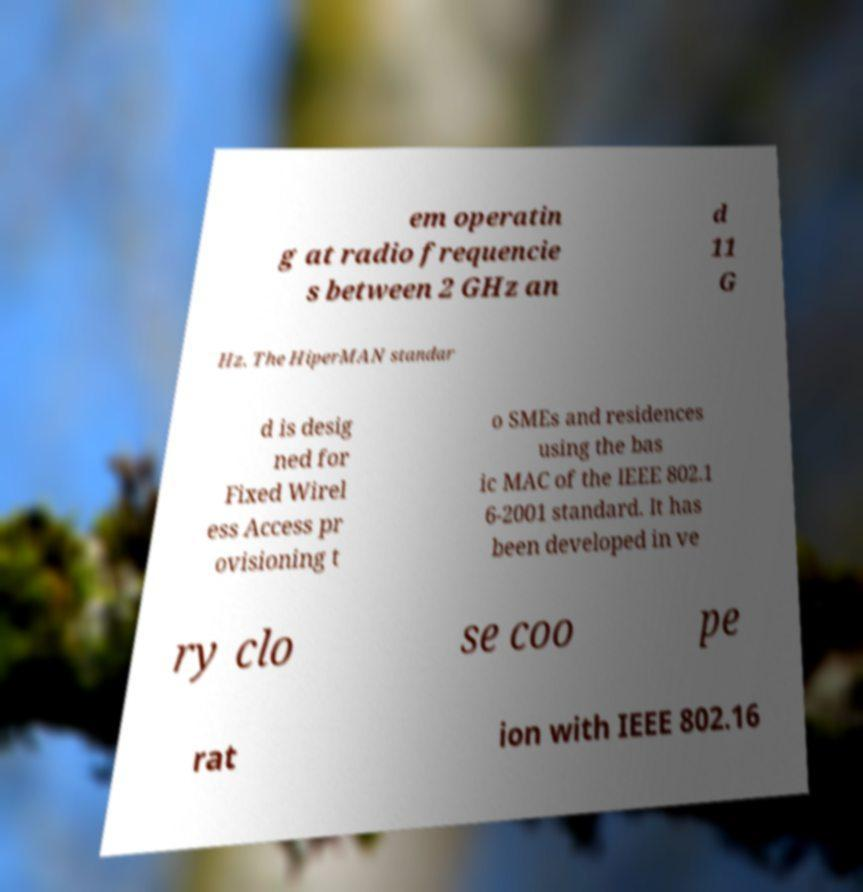Please identify and transcribe the text found in this image. em operatin g at radio frequencie s between 2 GHz an d 11 G Hz. The HiperMAN standar d is desig ned for Fixed Wirel ess Access pr ovisioning t o SMEs and residences using the bas ic MAC of the IEEE 802.1 6-2001 standard. It has been developed in ve ry clo se coo pe rat ion with IEEE 802.16 